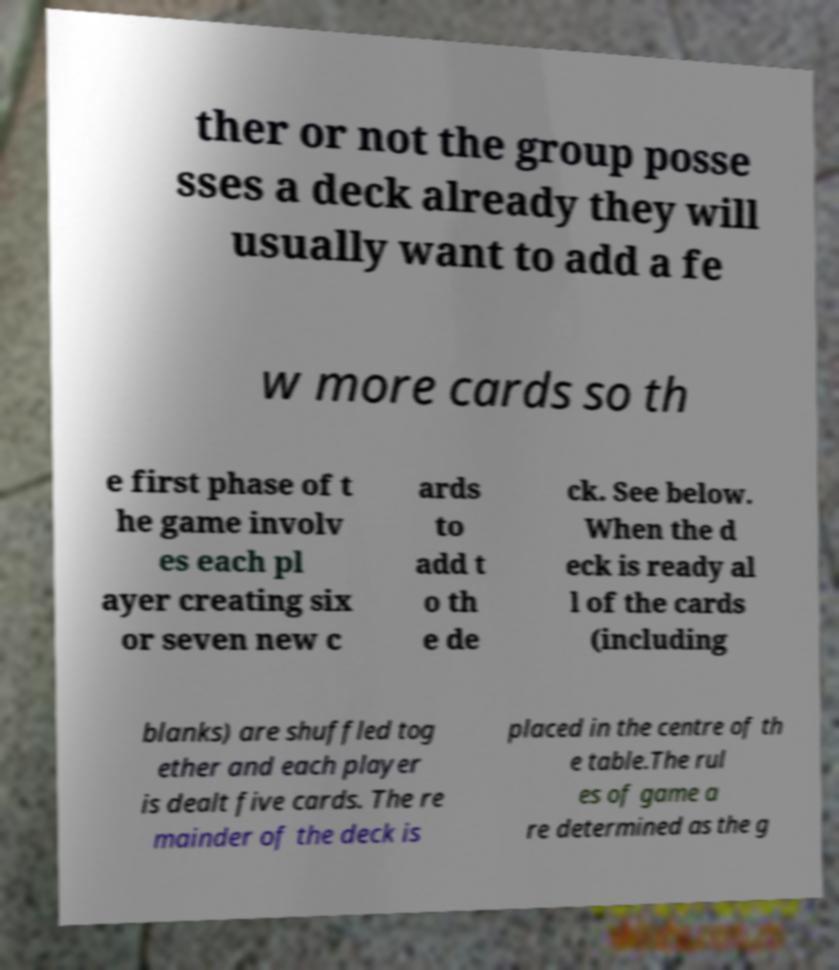Could you assist in decoding the text presented in this image and type it out clearly? ther or not the group posse sses a deck already they will usually want to add a fe w more cards so th e first phase of t he game involv es each pl ayer creating six or seven new c ards to add t o th e de ck. See below. When the d eck is ready al l of the cards (including blanks) are shuffled tog ether and each player is dealt five cards. The re mainder of the deck is placed in the centre of th e table.The rul es of game a re determined as the g 